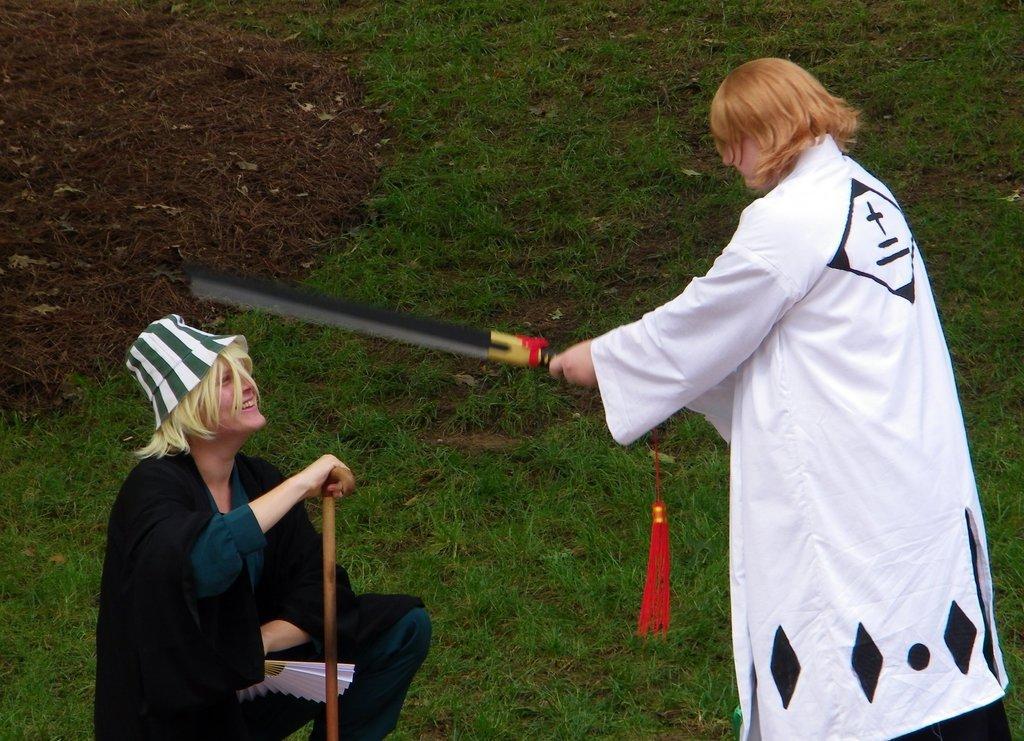Please provide a concise description of this image. In this image in front there are two people holding sticks. At the bottom of the image there is grass on the surface. 